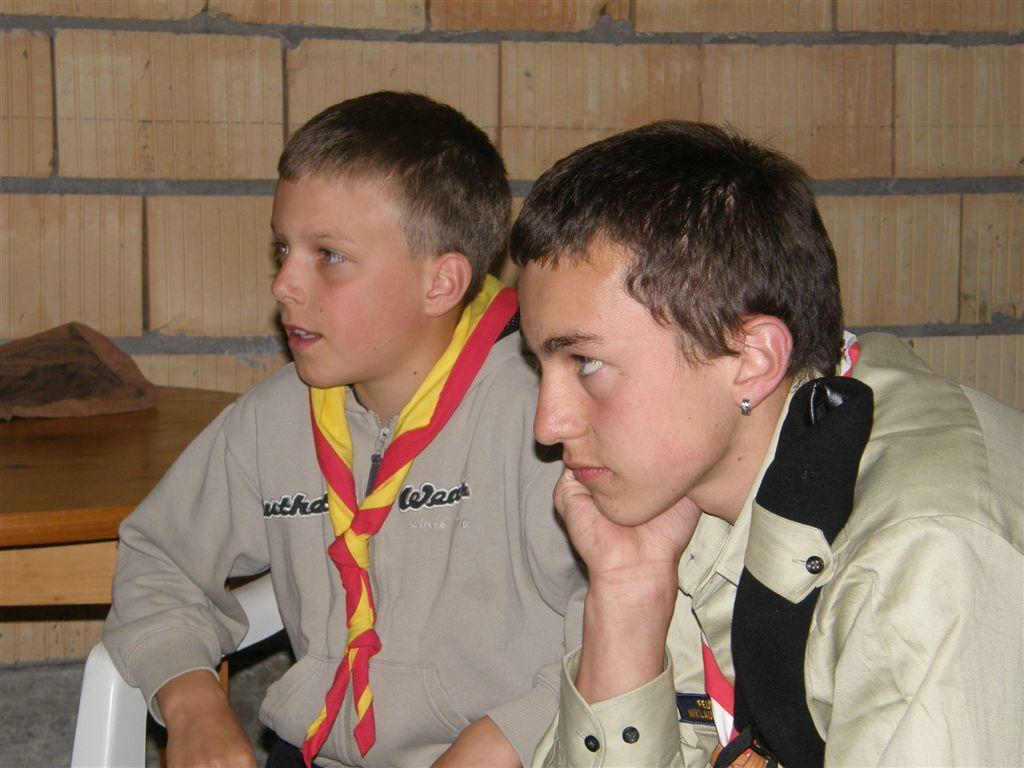How many boys are present in the image? There are two boys sitting in the image. What is the wooden object in the image? The wooden object in the image is not specified, but it is mentioned that there is a wooden object present. What is visible in the background of the image? There is a wall visible in the image. What type of division is being taught by the boys in the image? There is no indication in the image that the boys are teaching or learning any type of division. Can you tell me how many guides are present in the image? There is no guide present in the image. What is the wrist position of the boys in the image? The facts provided do not mention or describe the wrist position of the boys in the image. 